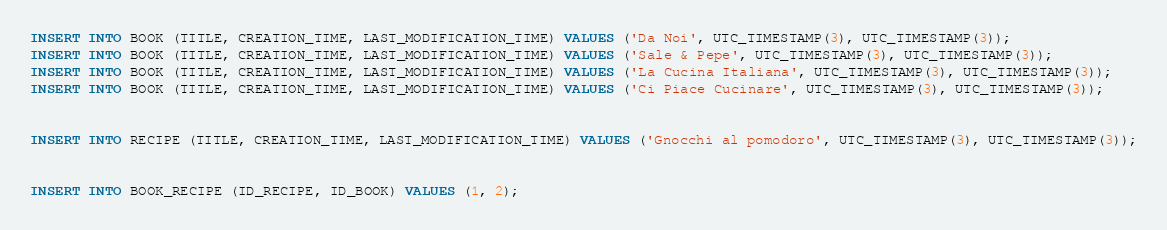Convert code to text. <code><loc_0><loc_0><loc_500><loc_500><_SQL_>INSERT INTO BOOK (TITLE, CREATION_TIME, LAST_MODIFICATION_TIME) VALUES ('Da Noi', UTC_TIMESTAMP(3), UTC_TIMESTAMP(3));
INSERT INTO BOOK (TITLE, CREATION_TIME, LAST_MODIFICATION_TIME) VALUES ('Sale & Pepe', UTC_TIMESTAMP(3), UTC_TIMESTAMP(3));
INSERT INTO BOOK (TITLE, CREATION_TIME, LAST_MODIFICATION_TIME) VALUES ('La Cucina Italiana', UTC_TIMESTAMP(3), UTC_TIMESTAMP(3));
INSERT INTO BOOK (TITLE, CREATION_TIME, LAST_MODIFICATION_TIME) VALUES ('Ci Piace Cucinare', UTC_TIMESTAMP(3), UTC_TIMESTAMP(3));


INSERT INTO RECIPE (TITLE, CREATION_TIME, LAST_MODIFICATION_TIME) VALUES ('Gnocchi al pomodoro', UTC_TIMESTAMP(3), UTC_TIMESTAMP(3));


INSERT INTO BOOK_RECIPE (ID_RECIPE, ID_BOOK) VALUES (1, 2);</code> 